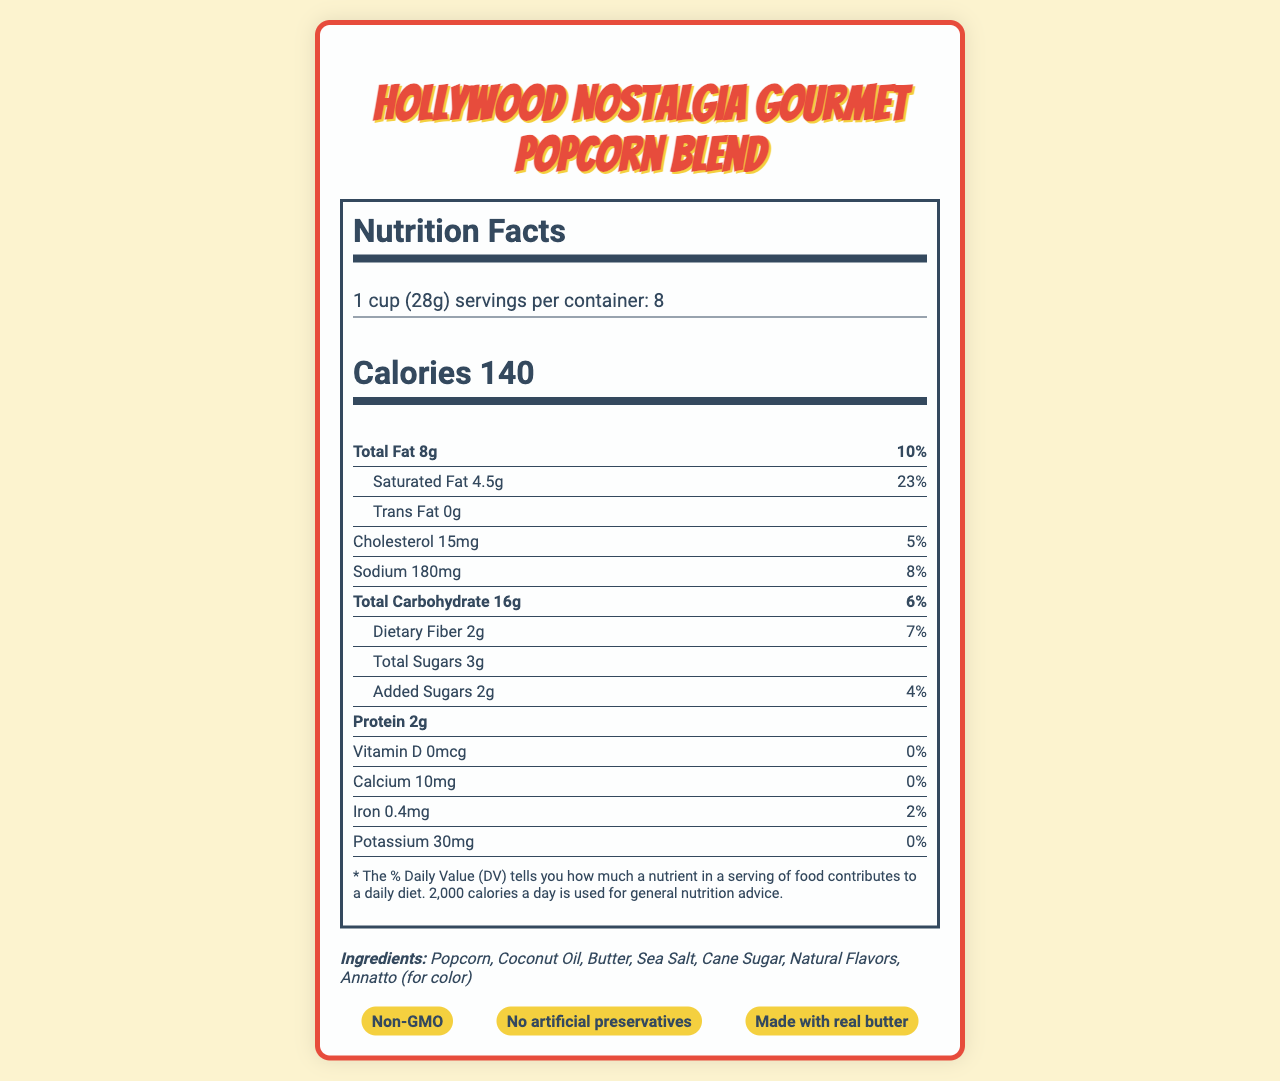what is the serving size of the Hollywood Nostalgia Gourmet Popcorn Blend? The serving size is clearly listed at the top of the nutrition label as "1 cup (28g)".
Answer: 1 cup (28g) how many servings are in one container? The document states there are 8 servings per container in the serving information section.
Answer: 8 how many calories are there per serving? The calorie content per serving is prominently displayed in the nutrition facts section as "Calories 140".
Answer: 140 what is the amount of total fat per serving? The total fat content is listed in the nutrition facts section as "Total Fat 8g".
Answer: 8g what percentage of the daily value of sodium does one serving contain? The sodium daily value percentage is noted as "8%" next to the sodium amount in the nutrition facts section.
Answer: 8% which ingredient listed provides color to the popcorn blend? The ingredients section lists "Annatto (for color)" as the color-providing ingredient.
Answer: Annatto Does the product contain any trans fat? The nutrition facts indicate "Trans Fat 0g", showing there is no trans fat.
Answer: No Which nutrient has the highest daily value percentage? A. Total Fat B. Saturated Fat C. Cholesterol D. Sodium Saturated Fat has the highest daily value percentage of 23% as indicated in the nutrition facts section.
Answer: B. Saturated Fat How much protein is there in one serving? A. 1g B. 2g C. 3g D. 4g The protein content per serving is listed as "Protein 2g" in the nutrition facts section.
Answer: B. 2g Is there any Vitamin D in the popcorn blend? The nutrition facts display "Vitamin D 0mcg" with a 0% daily value, indicating no Vitamin D content.
Answer: No Is this product suitable for someone avoiding dairy? The allergen information section states "Contains: Milk", indicating it is not suitable for someone avoiding dairy.
Answer: No What is the main inspiration behind the packaging design? The document mentions that the packaging is inspired by the golden age of movie theaters and blockbuster film releases.
Answer: The golden age of movie theaters and blockbuster film releases Summarize the nutrition information of the Hollywood Nostalgia Gourmet Popcorn Blend. This summary covers the essential nutrition information, including macronutrients, vitamins, and minerals, while highlighting the ingredients and allergens.
Answer: The Hollywood Nostalgia Gourmet Popcorn Blend provides 140 calories per serving, with a serving size of 1 cup (28g). It contains 8g total fat (10% DV), 4.5g saturated fat (23% DV), 0g trans fat, 15mg cholesterol (5% DV), 180mg sodium (8% DV), 16g total carbohydrates (6% DV), 2g dietary fiber (7% DV), 3g total sugars, including 2g added sugars (4% DV), and 2g protein. It contains minimal amounts of Vitamin D, calcium, and potassium, and 0.4mg iron (2% DV). Ingredients include popcorn, coconut oil, butter, sea salt, cane sugar, natural flavors, and annatto for color. The product contains milk. What is the exact amount of unsaturated fat in one serving? The document does not provide specific information about the amount of unsaturated fat in each serving. Only total fat and saturated fat are provided.
Answer: Cannot be determined 